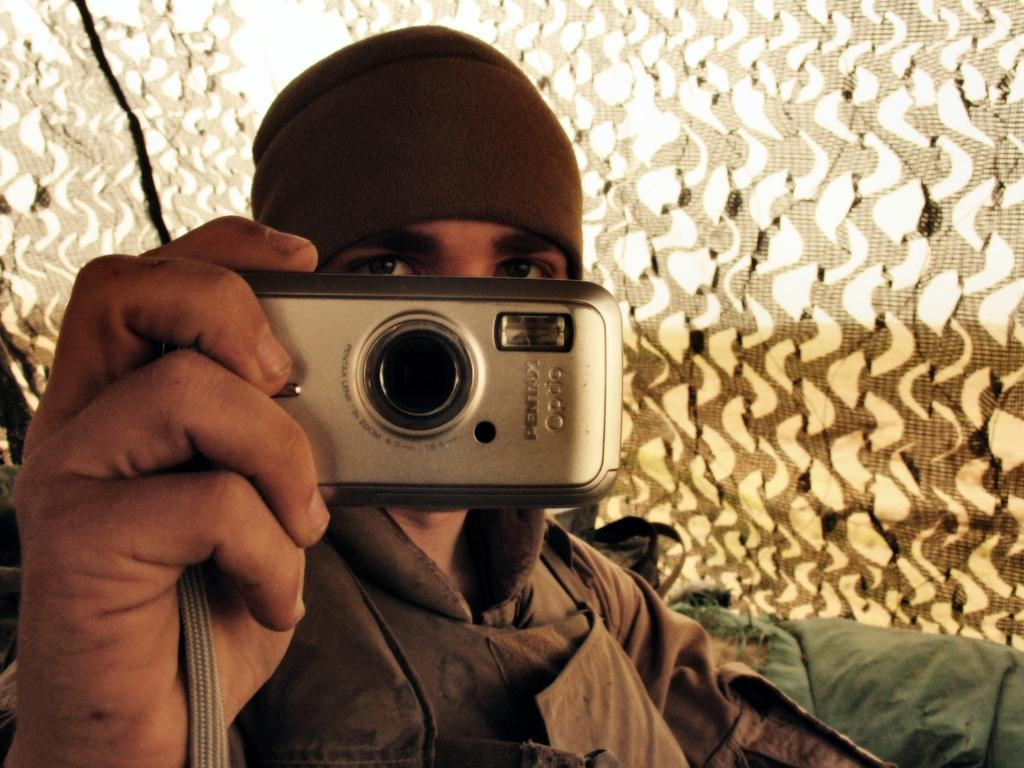What is the main subject of the image? There is a person in the image. What is the person holding in the image? The person is holding a camera. Can you describe the person's clothing in the image? The person is wearing a brown color coat. What color cloth can be seen in the image? There is green color cloth visible in the image. How would you describe the background of the image? The background of the image is in white and brown colors. What scientific discovery is the person making in the image? There is no indication of a scientific discovery being made in the image; the person is simply holding a camera. What nation is the person representing in the image? There is no information about the person's nationality or the nation they might be representing in the image. 